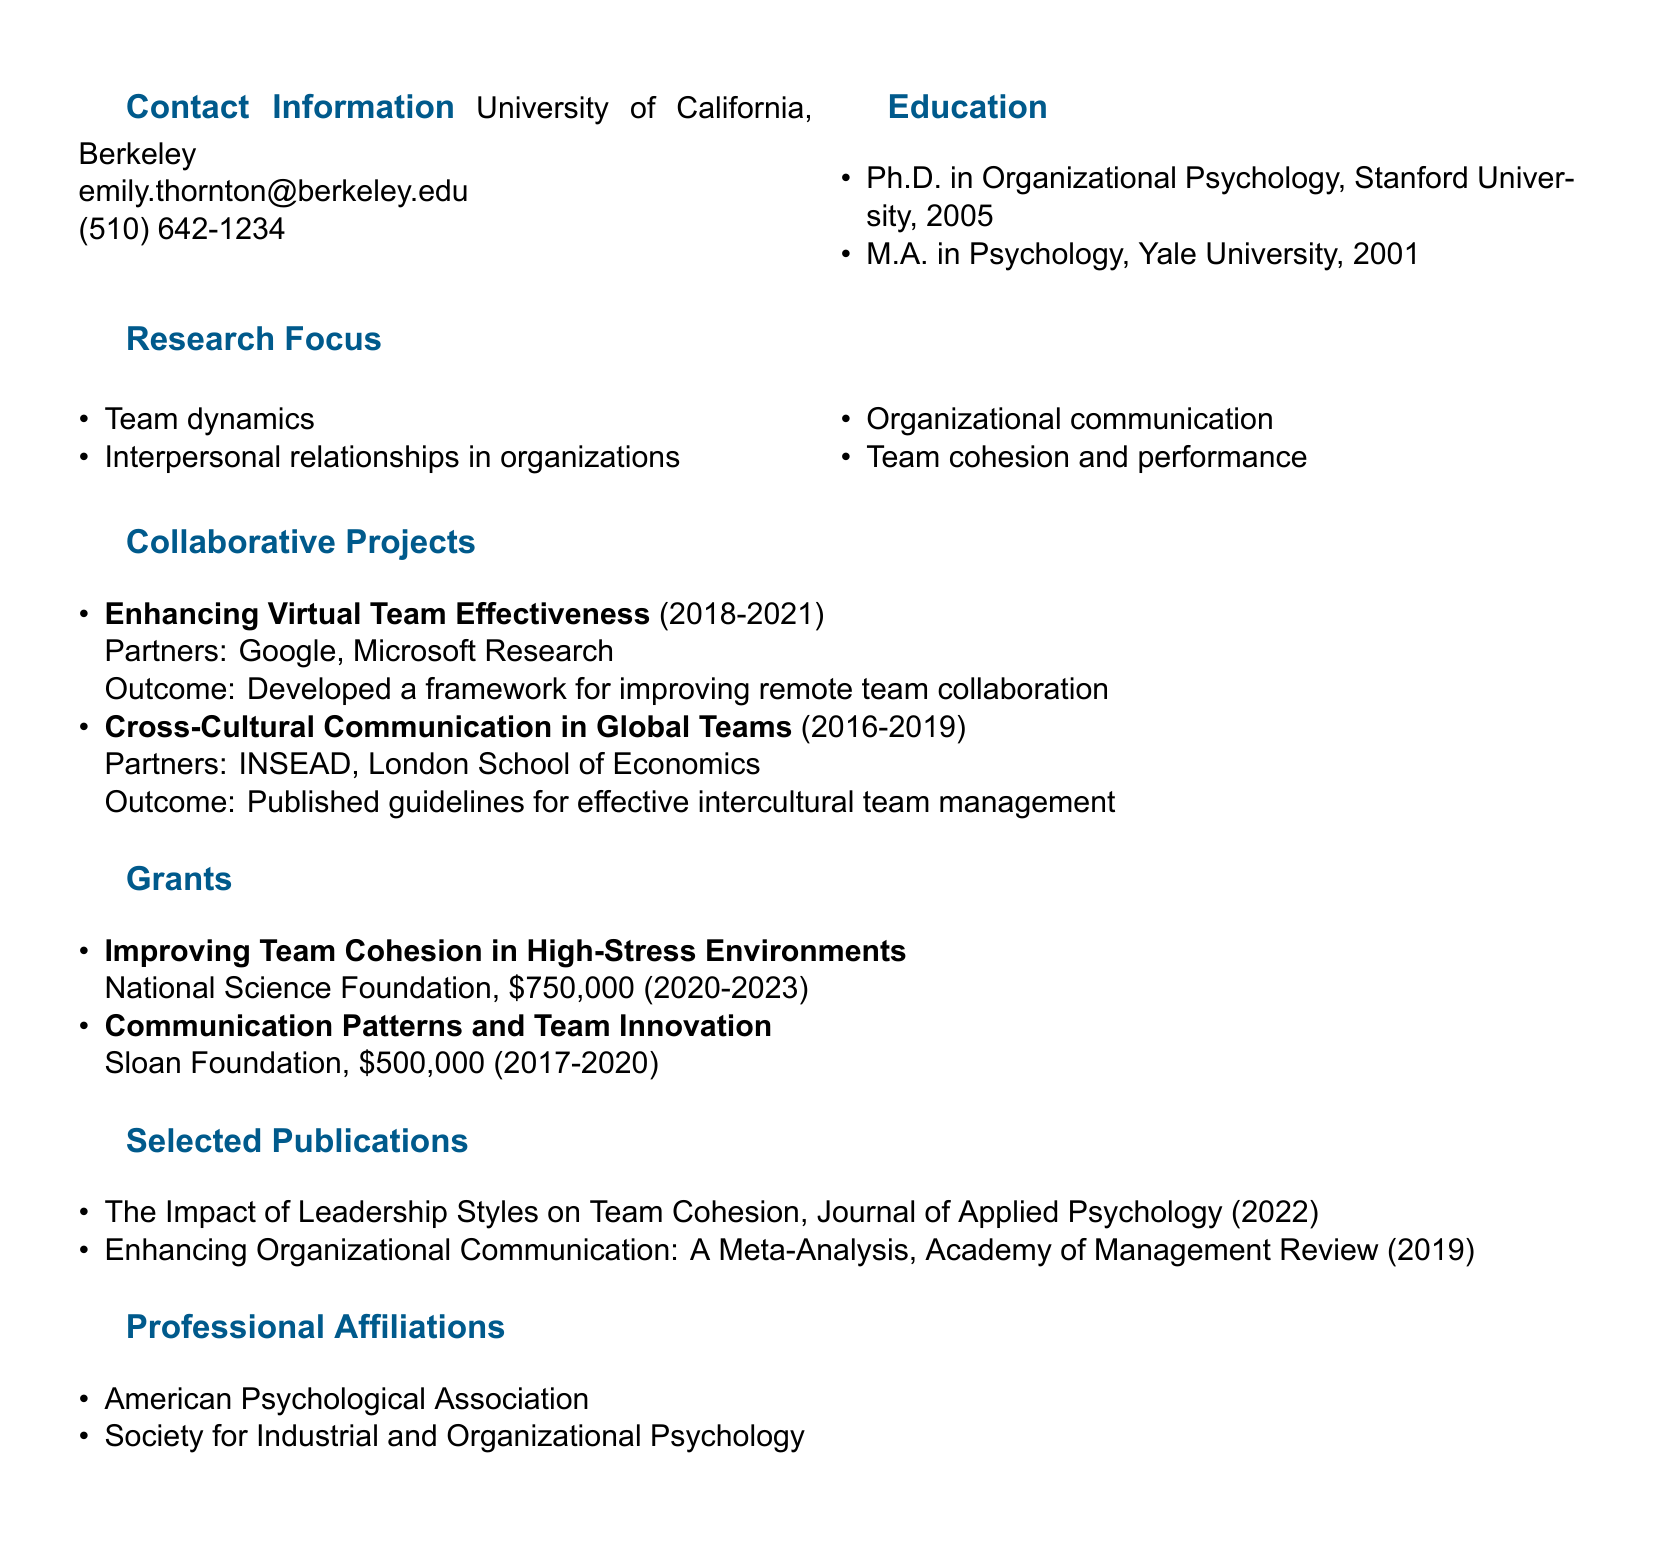what is the name of the professor? The name of the professor is stated at the top of the document under the header, which is Dr. Emily Thornton.
Answer: Dr. Emily Thornton where did Dr. Thornton receive her Ph.D.? The educational background lists Stanford University as the institution where she obtained her Ph.D. in Organizational Psychology.
Answer: Stanford University what was the duration of the collaborative project titled "Enhancing Virtual Team Effectiveness"? The duration is specified in the project list as starting in 2018 and ending in 2021.
Answer: 2018-2021 how much funding did the National Science Foundation grant Dr. Thornton? The grant list indicates that the amount provided by the National Science Foundation is $750,000 for the project mentioned.
Answer: $750,000 which journal published Dr. Thornton's work on leadership styles? The document lists the Journal of Applied Psychology as the publication for her work related to leadership styles.
Answer: Journal of Applied Psychology what area of research focuses on team cohesion and performance? The research focus section mentions team dynamics, interpersonal relationships, organizational communication, and team cohesion as relevant areas of study.
Answer: Team dynamics which professional organization is Dr. Thornton affiliated with? The professional affiliations section indicates membership in the American Psychological Association.
Answer: American Psychological Association how many collaborative projects are listed in Dr. Thornton's CV? A count of the projects in the collaborative projects section reveals there are two listed projects.
Answer: Two 